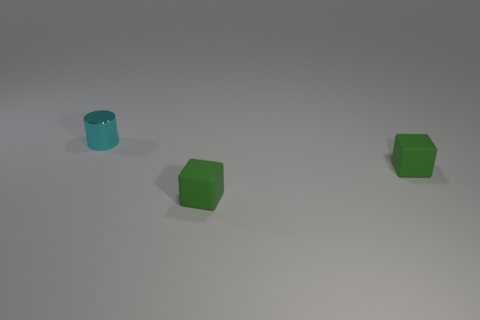Add 3 small green cubes. How many objects exist? 6 Subtract all cubes. How many objects are left? 1 Subtract all small cyan objects. Subtract all green matte cubes. How many objects are left? 0 Add 1 tiny cylinders. How many tiny cylinders are left? 2 Add 1 tiny rubber cubes. How many tiny rubber cubes exist? 3 Subtract 1 cyan cylinders. How many objects are left? 2 